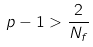<formula> <loc_0><loc_0><loc_500><loc_500>p - 1 > \frac { 2 } { N _ { f } }</formula> 